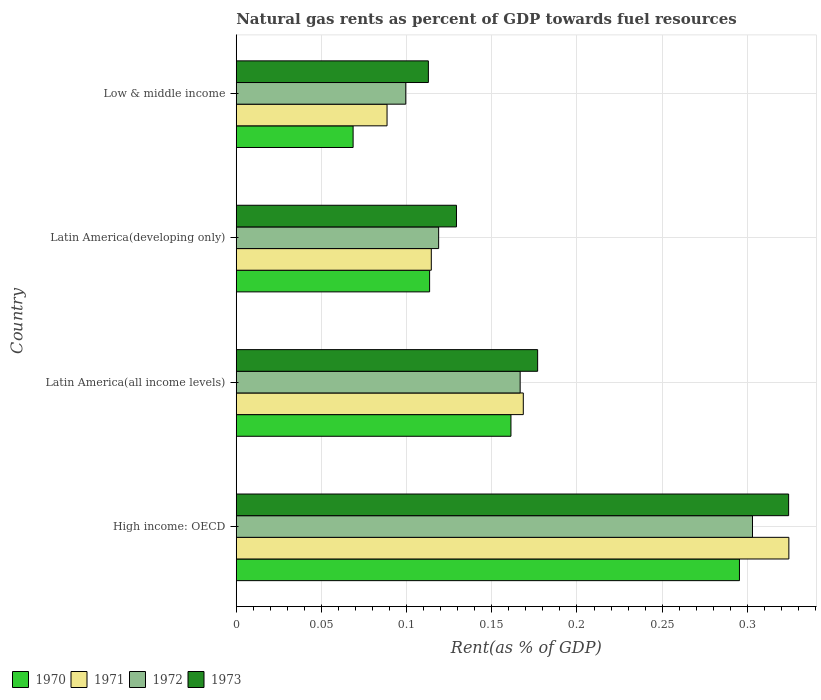How many groups of bars are there?
Keep it short and to the point. 4. Are the number of bars per tick equal to the number of legend labels?
Keep it short and to the point. Yes. Are the number of bars on each tick of the Y-axis equal?
Keep it short and to the point. Yes. How many bars are there on the 2nd tick from the top?
Offer a very short reply. 4. What is the label of the 1st group of bars from the top?
Your response must be concise. Low & middle income. What is the matural gas rent in 1973 in Low & middle income?
Provide a short and direct response. 0.11. Across all countries, what is the maximum matural gas rent in 1972?
Offer a terse response. 0.3. Across all countries, what is the minimum matural gas rent in 1971?
Provide a short and direct response. 0.09. In which country was the matural gas rent in 1970 maximum?
Your answer should be very brief. High income: OECD. In which country was the matural gas rent in 1972 minimum?
Offer a very short reply. Low & middle income. What is the total matural gas rent in 1973 in the graph?
Ensure brevity in your answer.  0.74. What is the difference between the matural gas rent in 1971 in Latin America(all income levels) and that in Low & middle income?
Provide a short and direct response. 0.08. What is the difference between the matural gas rent in 1971 in Latin America(all income levels) and the matural gas rent in 1970 in Low & middle income?
Your response must be concise. 0.1. What is the average matural gas rent in 1971 per country?
Your answer should be compact. 0.17. What is the difference between the matural gas rent in 1971 and matural gas rent in 1973 in High income: OECD?
Your response must be concise. 0. In how many countries, is the matural gas rent in 1970 greater than 0.24000000000000002 %?
Offer a very short reply. 1. What is the ratio of the matural gas rent in 1970 in High income: OECD to that in Latin America(all income levels)?
Your answer should be compact. 1.83. Is the difference between the matural gas rent in 1971 in Latin America(developing only) and Low & middle income greater than the difference between the matural gas rent in 1973 in Latin America(developing only) and Low & middle income?
Keep it short and to the point. Yes. What is the difference between the highest and the second highest matural gas rent in 1971?
Give a very brief answer. 0.16. What is the difference between the highest and the lowest matural gas rent in 1972?
Keep it short and to the point. 0.2. Is it the case that in every country, the sum of the matural gas rent in 1973 and matural gas rent in 1971 is greater than the sum of matural gas rent in 1970 and matural gas rent in 1972?
Ensure brevity in your answer.  No. What does the 3rd bar from the bottom in Low & middle income represents?
Your answer should be very brief. 1972. Are all the bars in the graph horizontal?
Ensure brevity in your answer.  Yes. How many countries are there in the graph?
Your answer should be compact. 4. What is the difference between two consecutive major ticks on the X-axis?
Ensure brevity in your answer.  0.05. Are the values on the major ticks of X-axis written in scientific E-notation?
Give a very brief answer. No. How are the legend labels stacked?
Give a very brief answer. Horizontal. What is the title of the graph?
Make the answer very short. Natural gas rents as percent of GDP towards fuel resources. Does "2004" appear as one of the legend labels in the graph?
Give a very brief answer. No. What is the label or title of the X-axis?
Offer a very short reply. Rent(as % of GDP). What is the Rent(as % of GDP) of 1970 in High income: OECD?
Your response must be concise. 0.3. What is the Rent(as % of GDP) of 1971 in High income: OECD?
Keep it short and to the point. 0.32. What is the Rent(as % of GDP) of 1972 in High income: OECD?
Give a very brief answer. 0.3. What is the Rent(as % of GDP) of 1973 in High income: OECD?
Ensure brevity in your answer.  0.32. What is the Rent(as % of GDP) of 1970 in Latin America(all income levels)?
Your response must be concise. 0.16. What is the Rent(as % of GDP) of 1971 in Latin America(all income levels)?
Ensure brevity in your answer.  0.17. What is the Rent(as % of GDP) in 1972 in Latin America(all income levels)?
Your answer should be compact. 0.17. What is the Rent(as % of GDP) in 1973 in Latin America(all income levels)?
Provide a succinct answer. 0.18. What is the Rent(as % of GDP) of 1970 in Latin America(developing only)?
Offer a very short reply. 0.11. What is the Rent(as % of GDP) in 1971 in Latin America(developing only)?
Your response must be concise. 0.11. What is the Rent(as % of GDP) of 1972 in Latin America(developing only)?
Your response must be concise. 0.12. What is the Rent(as % of GDP) in 1973 in Latin America(developing only)?
Offer a terse response. 0.13. What is the Rent(as % of GDP) in 1970 in Low & middle income?
Give a very brief answer. 0.07. What is the Rent(as % of GDP) in 1971 in Low & middle income?
Provide a short and direct response. 0.09. What is the Rent(as % of GDP) in 1972 in Low & middle income?
Make the answer very short. 0.1. What is the Rent(as % of GDP) of 1973 in Low & middle income?
Your response must be concise. 0.11. Across all countries, what is the maximum Rent(as % of GDP) in 1970?
Offer a very short reply. 0.3. Across all countries, what is the maximum Rent(as % of GDP) of 1971?
Make the answer very short. 0.32. Across all countries, what is the maximum Rent(as % of GDP) in 1972?
Provide a short and direct response. 0.3. Across all countries, what is the maximum Rent(as % of GDP) of 1973?
Offer a very short reply. 0.32. Across all countries, what is the minimum Rent(as % of GDP) in 1970?
Your answer should be compact. 0.07. Across all countries, what is the minimum Rent(as % of GDP) in 1971?
Make the answer very short. 0.09. Across all countries, what is the minimum Rent(as % of GDP) of 1972?
Offer a very short reply. 0.1. Across all countries, what is the minimum Rent(as % of GDP) in 1973?
Your answer should be compact. 0.11. What is the total Rent(as % of GDP) in 1970 in the graph?
Make the answer very short. 0.64. What is the total Rent(as % of GDP) of 1971 in the graph?
Offer a very short reply. 0.7. What is the total Rent(as % of GDP) in 1972 in the graph?
Your response must be concise. 0.69. What is the total Rent(as % of GDP) of 1973 in the graph?
Offer a very short reply. 0.74. What is the difference between the Rent(as % of GDP) in 1970 in High income: OECD and that in Latin America(all income levels)?
Keep it short and to the point. 0.13. What is the difference between the Rent(as % of GDP) in 1971 in High income: OECD and that in Latin America(all income levels)?
Offer a very short reply. 0.16. What is the difference between the Rent(as % of GDP) in 1972 in High income: OECD and that in Latin America(all income levels)?
Your answer should be very brief. 0.14. What is the difference between the Rent(as % of GDP) in 1973 in High income: OECD and that in Latin America(all income levels)?
Your response must be concise. 0.15. What is the difference between the Rent(as % of GDP) in 1970 in High income: OECD and that in Latin America(developing only)?
Your answer should be very brief. 0.18. What is the difference between the Rent(as % of GDP) of 1971 in High income: OECD and that in Latin America(developing only)?
Give a very brief answer. 0.21. What is the difference between the Rent(as % of GDP) of 1972 in High income: OECD and that in Latin America(developing only)?
Give a very brief answer. 0.18. What is the difference between the Rent(as % of GDP) of 1973 in High income: OECD and that in Latin America(developing only)?
Your answer should be very brief. 0.2. What is the difference between the Rent(as % of GDP) in 1970 in High income: OECD and that in Low & middle income?
Make the answer very short. 0.23. What is the difference between the Rent(as % of GDP) of 1971 in High income: OECD and that in Low & middle income?
Ensure brevity in your answer.  0.24. What is the difference between the Rent(as % of GDP) in 1972 in High income: OECD and that in Low & middle income?
Keep it short and to the point. 0.2. What is the difference between the Rent(as % of GDP) of 1973 in High income: OECD and that in Low & middle income?
Provide a short and direct response. 0.21. What is the difference between the Rent(as % of GDP) of 1970 in Latin America(all income levels) and that in Latin America(developing only)?
Provide a succinct answer. 0.05. What is the difference between the Rent(as % of GDP) of 1971 in Latin America(all income levels) and that in Latin America(developing only)?
Your answer should be very brief. 0.05. What is the difference between the Rent(as % of GDP) of 1972 in Latin America(all income levels) and that in Latin America(developing only)?
Give a very brief answer. 0.05. What is the difference between the Rent(as % of GDP) of 1973 in Latin America(all income levels) and that in Latin America(developing only)?
Your answer should be compact. 0.05. What is the difference between the Rent(as % of GDP) in 1970 in Latin America(all income levels) and that in Low & middle income?
Make the answer very short. 0.09. What is the difference between the Rent(as % of GDP) of 1972 in Latin America(all income levels) and that in Low & middle income?
Give a very brief answer. 0.07. What is the difference between the Rent(as % of GDP) of 1973 in Latin America(all income levels) and that in Low & middle income?
Provide a succinct answer. 0.06. What is the difference between the Rent(as % of GDP) of 1970 in Latin America(developing only) and that in Low & middle income?
Make the answer very short. 0.04. What is the difference between the Rent(as % of GDP) in 1971 in Latin America(developing only) and that in Low & middle income?
Your answer should be very brief. 0.03. What is the difference between the Rent(as % of GDP) of 1972 in Latin America(developing only) and that in Low & middle income?
Keep it short and to the point. 0.02. What is the difference between the Rent(as % of GDP) of 1973 in Latin America(developing only) and that in Low & middle income?
Make the answer very short. 0.02. What is the difference between the Rent(as % of GDP) in 1970 in High income: OECD and the Rent(as % of GDP) in 1971 in Latin America(all income levels)?
Offer a very short reply. 0.13. What is the difference between the Rent(as % of GDP) in 1970 in High income: OECD and the Rent(as % of GDP) in 1972 in Latin America(all income levels)?
Your answer should be compact. 0.13. What is the difference between the Rent(as % of GDP) in 1970 in High income: OECD and the Rent(as % of GDP) in 1973 in Latin America(all income levels)?
Your response must be concise. 0.12. What is the difference between the Rent(as % of GDP) in 1971 in High income: OECD and the Rent(as % of GDP) in 1972 in Latin America(all income levels)?
Make the answer very short. 0.16. What is the difference between the Rent(as % of GDP) of 1971 in High income: OECD and the Rent(as % of GDP) of 1973 in Latin America(all income levels)?
Your answer should be compact. 0.15. What is the difference between the Rent(as % of GDP) in 1972 in High income: OECD and the Rent(as % of GDP) in 1973 in Latin America(all income levels)?
Provide a succinct answer. 0.13. What is the difference between the Rent(as % of GDP) in 1970 in High income: OECD and the Rent(as % of GDP) in 1971 in Latin America(developing only)?
Keep it short and to the point. 0.18. What is the difference between the Rent(as % of GDP) in 1970 in High income: OECD and the Rent(as % of GDP) in 1972 in Latin America(developing only)?
Keep it short and to the point. 0.18. What is the difference between the Rent(as % of GDP) of 1970 in High income: OECD and the Rent(as % of GDP) of 1973 in Latin America(developing only)?
Your response must be concise. 0.17. What is the difference between the Rent(as % of GDP) in 1971 in High income: OECD and the Rent(as % of GDP) in 1972 in Latin America(developing only)?
Provide a short and direct response. 0.21. What is the difference between the Rent(as % of GDP) of 1971 in High income: OECD and the Rent(as % of GDP) of 1973 in Latin America(developing only)?
Ensure brevity in your answer.  0.2. What is the difference between the Rent(as % of GDP) of 1972 in High income: OECD and the Rent(as % of GDP) of 1973 in Latin America(developing only)?
Make the answer very short. 0.17. What is the difference between the Rent(as % of GDP) of 1970 in High income: OECD and the Rent(as % of GDP) of 1971 in Low & middle income?
Offer a terse response. 0.21. What is the difference between the Rent(as % of GDP) of 1970 in High income: OECD and the Rent(as % of GDP) of 1972 in Low & middle income?
Your answer should be very brief. 0.2. What is the difference between the Rent(as % of GDP) of 1970 in High income: OECD and the Rent(as % of GDP) of 1973 in Low & middle income?
Give a very brief answer. 0.18. What is the difference between the Rent(as % of GDP) of 1971 in High income: OECD and the Rent(as % of GDP) of 1972 in Low & middle income?
Offer a very short reply. 0.22. What is the difference between the Rent(as % of GDP) in 1971 in High income: OECD and the Rent(as % of GDP) in 1973 in Low & middle income?
Make the answer very short. 0.21. What is the difference between the Rent(as % of GDP) of 1972 in High income: OECD and the Rent(as % of GDP) of 1973 in Low & middle income?
Offer a very short reply. 0.19. What is the difference between the Rent(as % of GDP) of 1970 in Latin America(all income levels) and the Rent(as % of GDP) of 1971 in Latin America(developing only)?
Your answer should be very brief. 0.05. What is the difference between the Rent(as % of GDP) of 1970 in Latin America(all income levels) and the Rent(as % of GDP) of 1972 in Latin America(developing only)?
Give a very brief answer. 0.04. What is the difference between the Rent(as % of GDP) of 1970 in Latin America(all income levels) and the Rent(as % of GDP) of 1973 in Latin America(developing only)?
Ensure brevity in your answer.  0.03. What is the difference between the Rent(as % of GDP) of 1971 in Latin America(all income levels) and the Rent(as % of GDP) of 1972 in Latin America(developing only)?
Provide a succinct answer. 0.05. What is the difference between the Rent(as % of GDP) in 1971 in Latin America(all income levels) and the Rent(as % of GDP) in 1973 in Latin America(developing only)?
Ensure brevity in your answer.  0.04. What is the difference between the Rent(as % of GDP) in 1972 in Latin America(all income levels) and the Rent(as % of GDP) in 1973 in Latin America(developing only)?
Keep it short and to the point. 0.04. What is the difference between the Rent(as % of GDP) in 1970 in Latin America(all income levels) and the Rent(as % of GDP) in 1971 in Low & middle income?
Provide a short and direct response. 0.07. What is the difference between the Rent(as % of GDP) in 1970 in Latin America(all income levels) and the Rent(as % of GDP) in 1972 in Low & middle income?
Provide a short and direct response. 0.06. What is the difference between the Rent(as % of GDP) in 1970 in Latin America(all income levels) and the Rent(as % of GDP) in 1973 in Low & middle income?
Your answer should be very brief. 0.05. What is the difference between the Rent(as % of GDP) in 1971 in Latin America(all income levels) and the Rent(as % of GDP) in 1972 in Low & middle income?
Keep it short and to the point. 0.07. What is the difference between the Rent(as % of GDP) of 1971 in Latin America(all income levels) and the Rent(as % of GDP) of 1973 in Low & middle income?
Your answer should be compact. 0.06. What is the difference between the Rent(as % of GDP) of 1972 in Latin America(all income levels) and the Rent(as % of GDP) of 1973 in Low & middle income?
Provide a succinct answer. 0.05. What is the difference between the Rent(as % of GDP) of 1970 in Latin America(developing only) and the Rent(as % of GDP) of 1971 in Low & middle income?
Keep it short and to the point. 0.03. What is the difference between the Rent(as % of GDP) of 1970 in Latin America(developing only) and the Rent(as % of GDP) of 1972 in Low & middle income?
Provide a short and direct response. 0.01. What is the difference between the Rent(as % of GDP) in 1970 in Latin America(developing only) and the Rent(as % of GDP) in 1973 in Low & middle income?
Provide a succinct answer. 0. What is the difference between the Rent(as % of GDP) of 1971 in Latin America(developing only) and the Rent(as % of GDP) of 1972 in Low & middle income?
Your answer should be very brief. 0.01. What is the difference between the Rent(as % of GDP) of 1971 in Latin America(developing only) and the Rent(as % of GDP) of 1973 in Low & middle income?
Your answer should be compact. 0. What is the difference between the Rent(as % of GDP) in 1972 in Latin America(developing only) and the Rent(as % of GDP) in 1973 in Low & middle income?
Make the answer very short. 0.01. What is the average Rent(as % of GDP) of 1970 per country?
Keep it short and to the point. 0.16. What is the average Rent(as % of GDP) of 1971 per country?
Keep it short and to the point. 0.17. What is the average Rent(as % of GDP) of 1972 per country?
Offer a terse response. 0.17. What is the average Rent(as % of GDP) of 1973 per country?
Offer a very short reply. 0.19. What is the difference between the Rent(as % of GDP) of 1970 and Rent(as % of GDP) of 1971 in High income: OECD?
Give a very brief answer. -0.03. What is the difference between the Rent(as % of GDP) of 1970 and Rent(as % of GDP) of 1972 in High income: OECD?
Offer a terse response. -0.01. What is the difference between the Rent(as % of GDP) in 1970 and Rent(as % of GDP) in 1973 in High income: OECD?
Give a very brief answer. -0.03. What is the difference between the Rent(as % of GDP) in 1971 and Rent(as % of GDP) in 1972 in High income: OECD?
Make the answer very short. 0.02. What is the difference between the Rent(as % of GDP) in 1971 and Rent(as % of GDP) in 1973 in High income: OECD?
Your answer should be compact. 0. What is the difference between the Rent(as % of GDP) in 1972 and Rent(as % of GDP) in 1973 in High income: OECD?
Offer a very short reply. -0.02. What is the difference between the Rent(as % of GDP) of 1970 and Rent(as % of GDP) of 1971 in Latin America(all income levels)?
Give a very brief answer. -0.01. What is the difference between the Rent(as % of GDP) of 1970 and Rent(as % of GDP) of 1972 in Latin America(all income levels)?
Your answer should be compact. -0.01. What is the difference between the Rent(as % of GDP) in 1970 and Rent(as % of GDP) in 1973 in Latin America(all income levels)?
Offer a very short reply. -0.02. What is the difference between the Rent(as % of GDP) of 1971 and Rent(as % of GDP) of 1972 in Latin America(all income levels)?
Offer a very short reply. 0. What is the difference between the Rent(as % of GDP) in 1971 and Rent(as % of GDP) in 1973 in Latin America(all income levels)?
Offer a very short reply. -0.01. What is the difference between the Rent(as % of GDP) in 1972 and Rent(as % of GDP) in 1973 in Latin America(all income levels)?
Keep it short and to the point. -0.01. What is the difference between the Rent(as % of GDP) of 1970 and Rent(as % of GDP) of 1971 in Latin America(developing only)?
Keep it short and to the point. -0. What is the difference between the Rent(as % of GDP) in 1970 and Rent(as % of GDP) in 1972 in Latin America(developing only)?
Keep it short and to the point. -0.01. What is the difference between the Rent(as % of GDP) in 1970 and Rent(as % of GDP) in 1973 in Latin America(developing only)?
Your response must be concise. -0.02. What is the difference between the Rent(as % of GDP) in 1971 and Rent(as % of GDP) in 1972 in Latin America(developing only)?
Provide a short and direct response. -0. What is the difference between the Rent(as % of GDP) of 1971 and Rent(as % of GDP) of 1973 in Latin America(developing only)?
Your response must be concise. -0.01. What is the difference between the Rent(as % of GDP) in 1972 and Rent(as % of GDP) in 1973 in Latin America(developing only)?
Offer a terse response. -0.01. What is the difference between the Rent(as % of GDP) in 1970 and Rent(as % of GDP) in 1971 in Low & middle income?
Offer a terse response. -0.02. What is the difference between the Rent(as % of GDP) in 1970 and Rent(as % of GDP) in 1972 in Low & middle income?
Offer a very short reply. -0.03. What is the difference between the Rent(as % of GDP) of 1970 and Rent(as % of GDP) of 1973 in Low & middle income?
Your answer should be very brief. -0.04. What is the difference between the Rent(as % of GDP) of 1971 and Rent(as % of GDP) of 1972 in Low & middle income?
Your response must be concise. -0.01. What is the difference between the Rent(as % of GDP) of 1971 and Rent(as % of GDP) of 1973 in Low & middle income?
Provide a short and direct response. -0.02. What is the difference between the Rent(as % of GDP) of 1972 and Rent(as % of GDP) of 1973 in Low & middle income?
Your answer should be compact. -0.01. What is the ratio of the Rent(as % of GDP) in 1970 in High income: OECD to that in Latin America(all income levels)?
Keep it short and to the point. 1.83. What is the ratio of the Rent(as % of GDP) of 1971 in High income: OECD to that in Latin America(all income levels)?
Offer a very short reply. 1.93. What is the ratio of the Rent(as % of GDP) of 1972 in High income: OECD to that in Latin America(all income levels)?
Provide a short and direct response. 1.82. What is the ratio of the Rent(as % of GDP) of 1973 in High income: OECD to that in Latin America(all income levels)?
Your response must be concise. 1.83. What is the ratio of the Rent(as % of GDP) in 1970 in High income: OECD to that in Latin America(developing only)?
Your response must be concise. 2.6. What is the ratio of the Rent(as % of GDP) in 1971 in High income: OECD to that in Latin America(developing only)?
Make the answer very short. 2.83. What is the ratio of the Rent(as % of GDP) of 1972 in High income: OECD to that in Latin America(developing only)?
Keep it short and to the point. 2.55. What is the ratio of the Rent(as % of GDP) in 1973 in High income: OECD to that in Latin America(developing only)?
Offer a terse response. 2.51. What is the ratio of the Rent(as % of GDP) of 1970 in High income: OECD to that in Low & middle income?
Offer a very short reply. 4.31. What is the ratio of the Rent(as % of GDP) of 1971 in High income: OECD to that in Low & middle income?
Provide a succinct answer. 3.66. What is the ratio of the Rent(as % of GDP) in 1972 in High income: OECD to that in Low & middle income?
Offer a very short reply. 3.05. What is the ratio of the Rent(as % of GDP) of 1973 in High income: OECD to that in Low & middle income?
Give a very brief answer. 2.88. What is the ratio of the Rent(as % of GDP) in 1970 in Latin America(all income levels) to that in Latin America(developing only)?
Provide a short and direct response. 1.42. What is the ratio of the Rent(as % of GDP) of 1971 in Latin America(all income levels) to that in Latin America(developing only)?
Offer a very short reply. 1.47. What is the ratio of the Rent(as % of GDP) of 1972 in Latin America(all income levels) to that in Latin America(developing only)?
Your response must be concise. 1.4. What is the ratio of the Rent(as % of GDP) in 1973 in Latin America(all income levels) to that in Latin America(developing only)?
Offer a very short reply. 1.37. What is the ratio of the Rent(as % of GDP) in 1970 in Latin America(all income levels) to that in Low & middle income?
Make the answer very short. 2.35. What is the ratio of the Rent(as % of GDP) in 1971 in Latin America(all income levels) to that in Low & middle income?
Provide a short and direct response. 1.9. What is the ratio of the Rent(as % of GDP) of 1972 in Latin America(all income levels) to that in Low & middle income?
Your answer should be very brief. 1.67. What is the ratio of the Rent(as % of GDP) of 1973 in Latin America(all income levels) to that in Low & middle income?
Offer a very short reply. 1.57. What is the ratio of the Rent(as % of GDP) in 1970 in Latin America(developing only) to that in Low & middle income?
Give a very brief answer. 1.65. What is the ratio of the Rent(as % of GDP) of 1971 in Latin America(developing only) to that in Low & middle income?
Your answer should be very brief. 1.29. What is the ratio of the Rent(as % of GDP) of 1972 in Latin America(developing only) to that in Low & middle income?
Provide a short and direct response. 1.19. What is the ratio of the Rent(as % of GDP) in 1973 in Latin America(developing only) to that in Low & middle income?
Offer a terse response. 1.15. What is the difference between the highest and the second highest Rent(as % of GDP) of 1970?
Provide a succinct answer. 0.13. What is the difference between the highest and the second highest Rent(as % of GDP) of 1971?
Provide a short and direct response. 0.16. What is the difference between the highest and the second highest Rent(as % of GDP) of 1972?
Make the answer very short. 0.14. What is the difference between the highest and the second highest Rent(as % of GDP) of 1973?
Keep it short and to the point. 0.15. What is the difference between the highest and the lowest Rent(as % of GDP) in 1970?
Keep it short and to the point. 0.23. What is the difference between the highest and the lowest Rent(as % of GDP) of 1971?
Make the answer very short. 0.24. What is the difference between the highest and the lowest Rent(as % of GDP) of 1972?
Make the answer very short. 0.2. What is the difference between the highest and the lowest Rent(as % of GDP) of 1973?
Offer a very short reply. 0.21. 